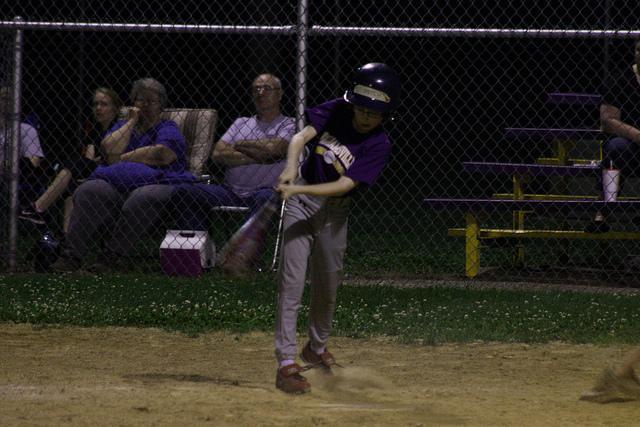If the boy is unsuccessful in doing what he is doing three times in a row what is it called?
Answer the question by selecting the correct answer among the 4 following choices.
Options: Flag, strikeout, penalty, base hit. Strikeout. 